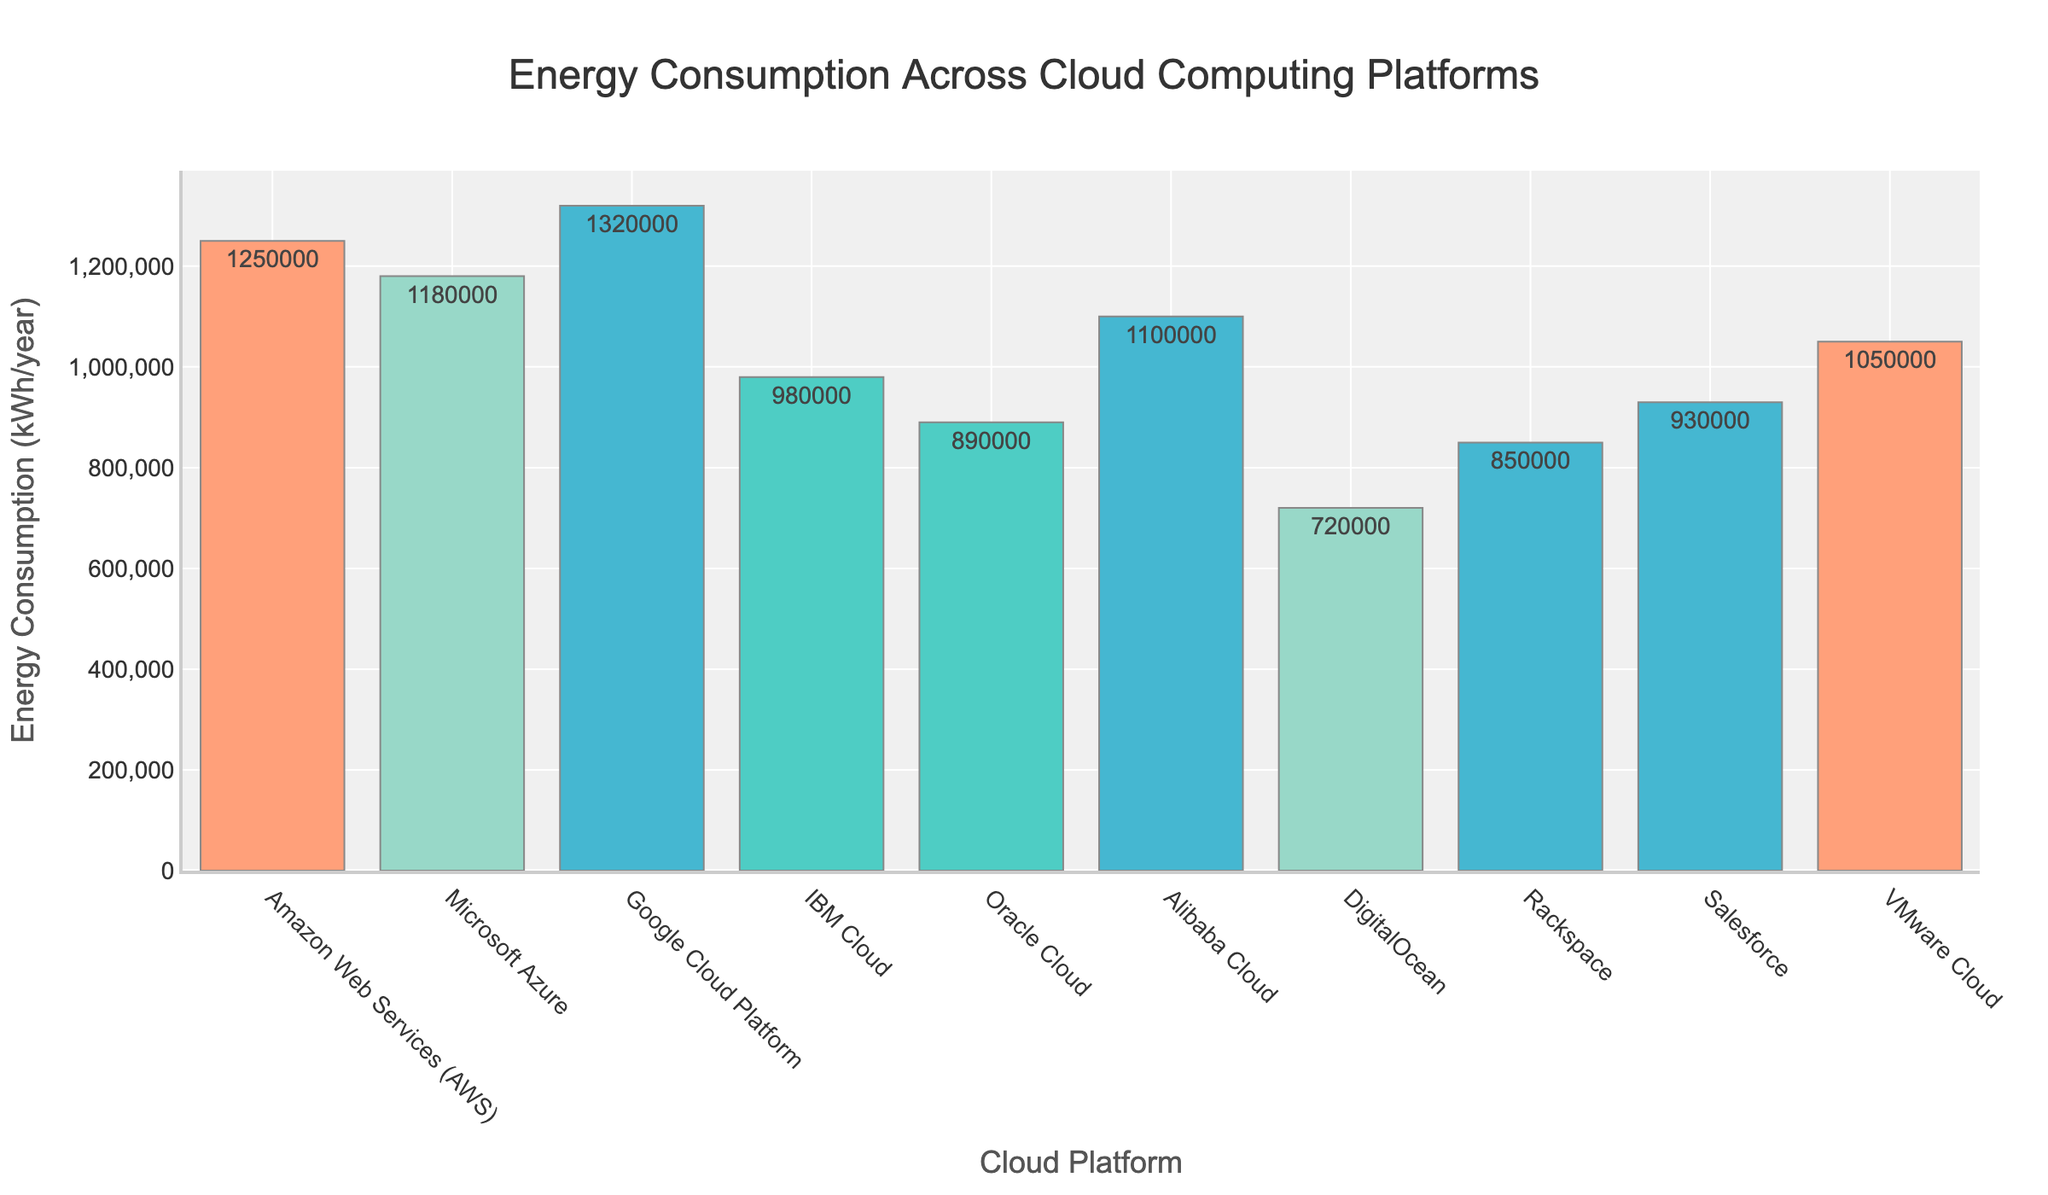Which cloud platform has the highest energy consumption? From the figure, Google Cloud Platform has the tallest bar, indicating the highest energy consumption among the listed platforms.
Answer: Google Cloud Platform Which cloud platform has the lowest energy consumption? By observing the figure, DigitalOcean has the shortest bar, thus the lowest energy consumption compared to other platforms.
Answer: DigitalOcean How much more energy does AWS consume compared to Oracle Cloud? AWS consumes 1,250,000 kWh/year and Oracle Cloud consumes 890,000 kWh/year. Subtracting the two values gives the difference: 1,250,000 - 890,000 = 360,000 kWh/year.
Answer: 360,000 kWh/year Which platform has a slightly higher energy consumption than IBM Cloud? IBM Cloud's energy consumption is 980,000 kWh/year. Scanning nearby bars, Salesforce is slightly higher at 930,000 kWh/year.
Answer: Salesforce What is the total energy consumption of Alibaba Cloud and VMware Cloud combined? Alibaba Cloud consumes 1,100,000 kWh/year and VMware Cloud consumes 1,050,000 kWh/year. The total combined consumption is 1,100,000 + 1,050,000 = 2,150,000 kWh/year.
Answer: 2,150,000 kWh/year How does DigitalOcean's energy consumption compare to Rackspace's? Comparing the heights of the bars, DigitalOcean (720,000 kWh/year) consumes less energy than Rackspace (850,000 kWh/year).
Answer: Less Is the energy consumption of Microsoft Azure greater than Amazon Web Services? Looking at the bars, Microsoft Azure's energy consumption is lower (1,180,000 kWh/year) compared to Amazon Web Services (1,250,000 kWh/year).
Answer: No What is the average energy consumption of the top three energy-consuming platforms? The top three platforms by energy consumption are Google Cloud Platform (1,320,000 kWh/year), Amazon Web Services (1,250,000 kWh/year), and Microsoft Azure (1,180,000 kWh/year). The average is calculated as (1,320,000 + 1,250,000 + 1,180,000) / 3 = 1,250,000 kWh/year.
Answer: 1,250,000 kWh/year Which platform consumes more energy, VMware Cloud or DigitalOcean? VMware Cloud consumes 1,050,000 kWh/year while DigitalOcean consumes 720,000 kWh/year. VMware Cloud consumes more energy.
Answer: VMware Cloud Which two platforms' combined energy consumption is closest to Google Cloud Platform's? Google Cloud Platform consumes 1,320,000 kWh/year. The combined energy consumption of AWS (1,250,000 kWh/year) and Rackspace (850,000 kWh/year) is 1,250,000 + 850,000 = 2,100,000 kWh/year. The combination of Alibaba Cloud (1,100,000 kWh/year) and Salesforce (930,000 kWh/year) is 1,100,000 + 930,000 = 2,030,000 kWh/year. The closest combination is Alibaba Cloud and VMware Cloud: 1,100,000 + 1,050,000 = 2,150,000 kWh/year. None of these combinations is closer to Google Cloud Platform's energy consumption.
Answer: None 